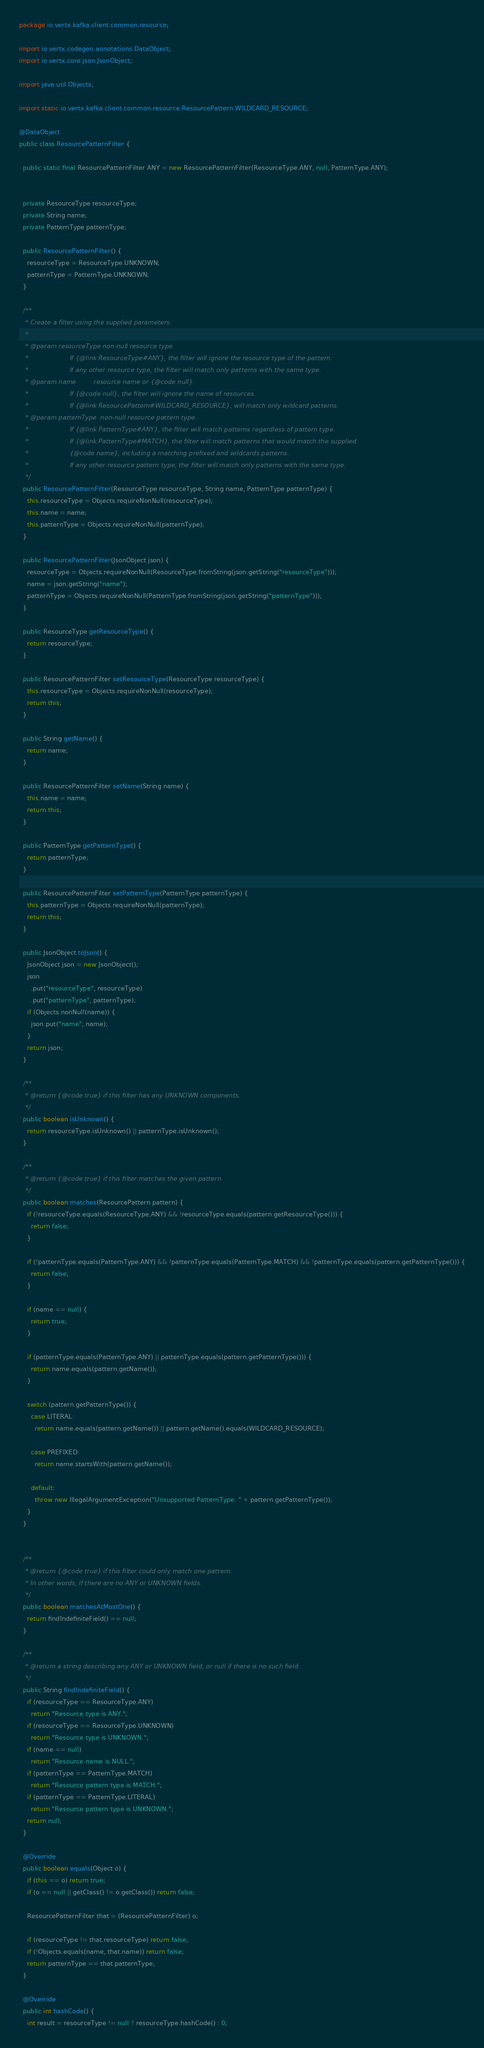<code> <loc_0><loc_0><loc_500><loc_500><_Java_>package io.vertx.kafka.client.common.resource;

import io.vertx.codegen.annotations.DataObject;
import io.vertx.core.json.JsonObject;

import java.util.Objects;

import static io.vertx.kafka.client.common.resource.ResourcePattern.WILDCARD_RESOURCE;

@DataObject
public class ResourcePatternFilter {

  public static final ResourcePatternFilter ANY = new ResourcePatternFilter(ResourceType.ANY, null, PatternType.ANY);


  private ResourceType resourceType;
  private String name;
  private PatternType patternType;

  public ResourcePatternFilter() {
    resourceType = ResourceType.UNKNOWN;
    patternType = PatternType.UNKNOWN;
  }

  /**
   * Create a filter using the supplied parameters.
   *
   * @param resourceType non-null resource type.
   *                     If {@link ResourceType#ANY}, the filter will ignore the resource type of the pattern.
   *                     If any other resource type, the filter will match only patterns with the same type.
   * @param name         resource name or {@code null}.
   *                     If {@code null}, the filter will ignore the name of resources.
   *                     If {@link ResourcePattern#WILDCARD_RESOURCE}, will match only wildcard patterns.
   * @param patternType  non-null resource pattern type.
   *                     If {@link PatternType#ANY}, the filter will match patterns regardless of pattern type.
   *                     If {@link PatternType#MATCH}, the filter will match patterns that would match the supplied
   *                     {@code name}, including a matching prefixed and wildcards patterns.
   *                     If any other resource pattern type, the filter will match only patterns with the same type.
   */
  public ResourcePatternFilter(ResourceType resourceType, String name, PatternType patternType) {
    this.resourceType = Objects.requireNonNull(resourceType);
    this.name = name;
    this.patternType = Objects.requireNonNull(patternType);
  }

  public ResourcePatternFilter(JsonObject json) {
    resourceType = Objects.requireNonNull(ResourceType.fromString(json.getString("resourceType")));
    name = json.getString("name");
    patternType = Objects.requireNonNull(PatternType.fromString(json.getString("patternType")));
  }

  public ResourceType getResourceType() {
    return resourceType;
  }

  public ResourcePatternFilter setResourceType(ResourceType resourceType) {
    this.resourceType = Objects.requireNonNull(resourceType);
    return this;
  }

  public String getName() {
    return name;
  }

  public ResourcePatternFilter setName(String name) {
    this.name = name;
    return this;
  }

  public PatternType getPatternType() {
    return patternType;
  }

  public ResourcePatternFilter setPatternType(PatternType patternType) {
    this.patternType = Objects.requireNonNull(patternType);
    return this;
  }

  public JsonObject toJson() {
    JsonObject json = new JsonObject();
    json
      .put("resourceType", resourceType)
      .put("patternType", patternType);
    if (Objects.nonNull(name)) {
      json.put("name", name);
    }
    return json;
  }

  /**
   * @return {@code true} if this filter has any UNKNOWN components.
   */
  public boolean isUnknown() {
    return resourceType.isUnknown() || patternType.isUnknown();
  }

  /**
   * @return {@code true} if this filter matches the given pattern.
   */
  public boolean matches(ResourcePattern pattern) {
    if (!resourceType.equals(ResourceType.ANY) && !resourceType.equals(pattern.getResourceType())) {
      return false;
    }

    if (!patternType.equals(PatternType.ANY) && !patternType.equals(PatternType.MATCH) && !patternType.equals(pattern.getPatternType())) {
      return false;
    }

    if (name == null) {
      return true;
    }

    if (patternType.equals(PatternType.ANY) || patternType.equals(pattern.getPatternType())) {
      return name.equals(pattern.getName());
    }

    switch (pattern.getPatternType()) {
      case LITERAL:
        return name.equals(pattern.getName()) || pattern.getName().equals(WILDCARD_RESOURCE);

      case PREFIXED:
        return name.startsWith(pattern.getName());

      default:
        throw new IllegalArgumentException("Unsupported PatternType: " + pattern.getPatternType());
    }
  }


  /**
   * @return {@code true} if this filter could only match one pattern.
   * In other words, if there are no ANY or UNKNOWN fields.
   */
  public boolean matchesAtMostOne() {
    return findIndefiniteField() == null;
  }

  /**
   * @return a string describing any ANY or UNKNOWN field, or null if there is no such field.
   */
  public String findIndefiniteField() {
    if (resourceType == ResourceType.ANY)
      return "Resource type is ANY.";
    if (resourceType == ResourceType.UNKNOWN)
      return "Resource type is UNKNOWN.";
    if (name == null)
      return "Resource name is NULL.";
    if (patternType == PatternType.MATCH)
      return "Resource pattern type is MATCH.";
    if (patternType == PatternType.LITERAL)
      return "Resource pattern type is UNKNOWN.";
    return null;
  }

  @Override
  public boolean equals(Object o) {
    if (this == o) return true;
    if (o == null || getClass() != o.getClass()) return false;

    ResourcePatternFilter that = (ResourcePatternFilter) o;

    if (resourceType != that.resourceType) return false;
    if (!Objects.equals(name, that.name)) return false;
    return patternType == that.patternType;
  }

  @Override
  public int hashCode() {
    int result = resourceType != null ? resourceType.hashCode() : 0;</code> 